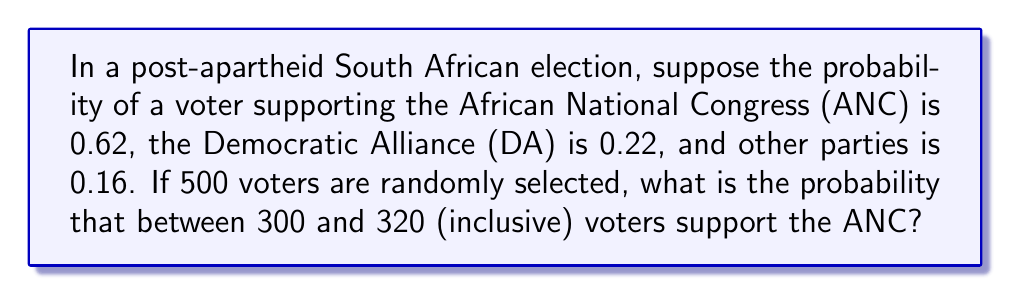What is the answer to this math problem? To solve this problem, we'll use the normal approximation to the binomial distribution:

1) First, we need to check if the normal approximation is appropriate:
   $np = 500 * 0.62 = 310$ and $n(1-p) = 500 * 0.38 = 190$
   Both are greater than 5, so we can use the normal approximation.

2) Calculate the mean ($\mu$) and standard deviation ($\sigma$) of the normal distribution:
   $\mu = np = 500 * 0.62 = 310$
   $\sigma = \sqrt{np(1-p)} = \sqrt{500 * 0.62 * 0.38} = \sqrt{117.8} \approx 10.85$

3) Calculate the z-scores for the lower and upper bounds:
   $z_{lower} = \frac{299.5 - 310}{10.85} \approx -0.97$
   $z_{upper} = \frac{320.5 - 310}{10.85} \approx 0.97$

4) Find the area under the standard normal curve between these z-scores:
   $P(299.5 < X < 320.5) = P(-0.97 < Z < 0.97)$
   $= \Phi(0.97) - \Phi(-0.97)$
   $= 0.8340 - 0.1660 = 0.6680$

Where $\Phi(z)$ is the cumulative distribution function of the standard normal distribution.
Answer: 0.6680 